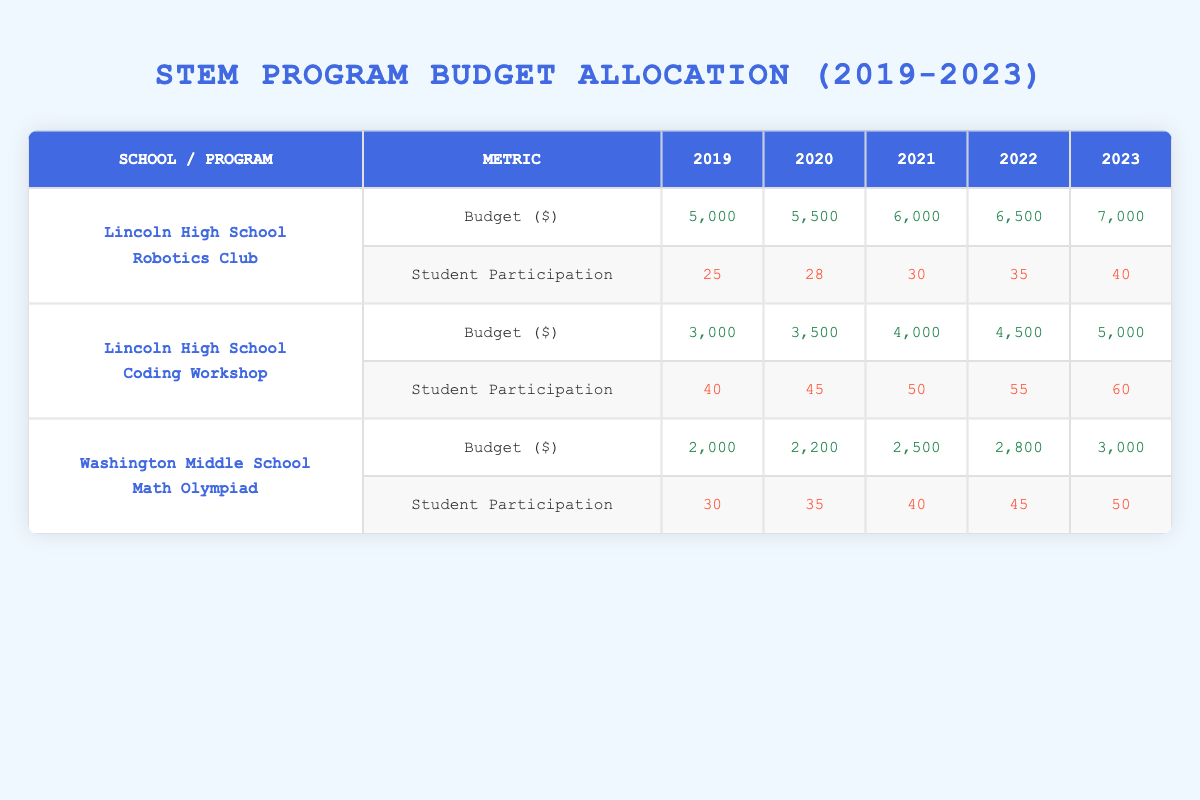What was the highest budget allocated for the Coding Workshop between 2019 and 2023? The highest budget for the Coding Workshop was in 2023, which was $5,000. You can find this by looking across the budget row for the Coding Workshop and identifying the maximum value.
Answer: $5,000 How many students participated in the Robotics Club in 2021? In 2021, 30 students participated in the Robotics Club. This value is directly located in the student participation row for Lincoln High School's Robotics Club in that year.
Answer: 30 What is the total budget allocated for the Math Olympiad from 2019 to 2023? The total budget for the Math Olympiad can be calculated by adding the amounts for each year: $2,000 (2019) + $2,200 (2020) + $2,500 (2021) + $2,800 (2022) + $3,000 (2023) = $12,500.
Answer: $12,500 Did Lincoln High School allocate more budget to the Robotics Club than the Coding Workshop in 2022? No, in 2022, the budget for Robotics Club was $6,500 while for Coding Workshop it was $4,500. Since $6,500 is greater than $4,500, the statement is true.
Answer: Yes What is the average student participation in the Coding Workshop over the five years? To find the average, we need to sum the participations: 40 (2019) + 45 (2020) + 50 (2021) + 55 (2022) + 60 (2023) = 250. Divide this sum by 5, the number of years: 250 / 5 = 50.
Answer: 50 In which year did Washington Middle School allocate the least budget for the Math Olympiad? Washington Middle School had the least budget for the Math Olympiad in 2019, which was $2,000, as listed in the corresponding budget row.
Answer: 2019 What was the increase in budget for the Robotics Club from 2019 to 2023? The budget for the Robotics Club in 2019 was $5,000 and in 2023 it was $7,000. The increase is calculated by subtracting the 2019 budget from the 2023 budget: $7,000 - $5,000 = $2,000.
Answer: $2,000 Is it true that student participation in the Math Olympiad increased every year from 2019 to 2023? Yes, the student participation for the Math Olympiad increased each year: 30 (2019), 35 (2020), 40 (2021), 45 (2022), and 50 (2023). Therefore, the statement is true.
Answer: Yes 